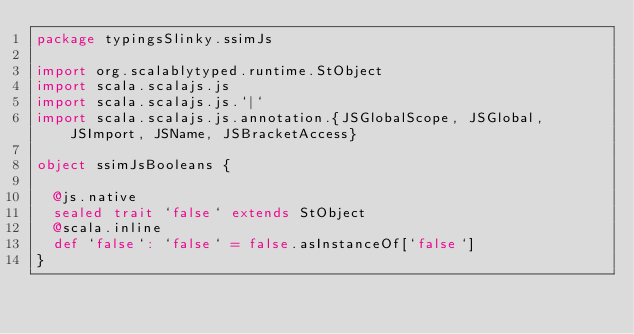Convert code to text. <code><loc_0><loc_0><loc_500><loc_500><_Scala_>package typingsSlinky.ssimJs

import org.scalablytyped.runtime.StObject
import scala.scalajs.js
import scala.scalajs.js.`|`
import scala.scalajs.js.annotation.{JSGlobalScope, JSGlobal, JSImport, JSName, JSBracketAccess}

object ssimJsBooleans {
  
  @js.native
  sealed trait `false` extends StObject
  @scala.inline
  def `false`: `false` = false.asInstanceOf[`false`]
}
</code> 